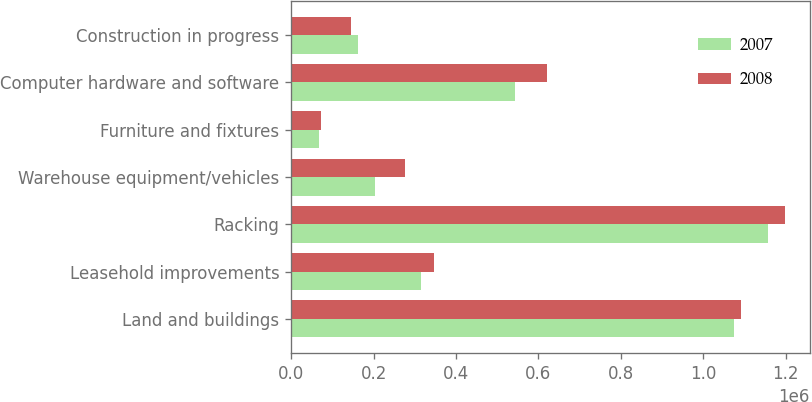<chart> <loc_0><loc_0><loc_500><loc_500><stacked_bar_chart><ecel><fcel>Land and buildings<fcel>Leasehold improvements<fcel>Racking<fcel>Warehouse equipment/vehicles<fcel>Furniture and fixtures<fcel>Computer hardware and software<fcel>Construction in progress<nl><fcel>2007<fcel>1.07355e+06<fcel>314858<fcel>1.15802e+06<fcel>202496<fcel>68091<fcel>543535<fcel>161980<nl><fcel>2008<fcel>1.09134e+06<fcel>346837<fcel>1.19802e+06<fcel>275866<fcel>72678<fcel>620922<fcel>144857<nl></chart> 